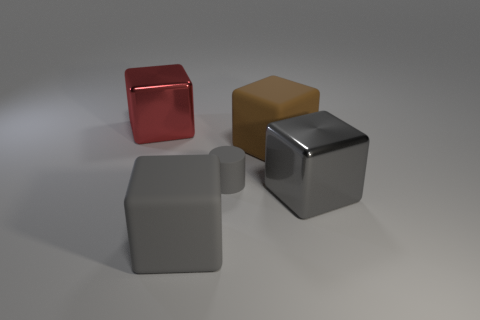Is there anything else that has the same material as the big brown cube?
Provide a short and direct response. Yes. Do the gray thing right of the gray rubber cylinder and the big brown object have the same material?
Ensure brevity in your answer.  No. There is a gray block behind the block that is in front of the large gray thing that is right of the big brown block; what is its material?
Make the answer very short. Metal. What number of other things are the same shape as the red metal object?
Offer a very short reply. 3. What is the color of the big rubber cube right of the tiny gray cylinder?
Offer a terse response. Brown. There is a gray object that is in front of the big metal object in front of the tiny object; what number of brown blocks are behind it?
Provide a short and direct response. 1. There is a metal object that is on the right side of the brown rubber object; how many big gray metal objects are behind it?
Ensure brevity in your answer.  0. How many big gray objects are on the left side of the gray rubber cube?
Offer a terse response. 0. How many other objects are there of the same size as the gray matte cylinder?
Provide a short and direct response. 0. There is a gray rubber object that is the same shape as the big gray metal object; what is its size?
Offer a terse response. Large. 